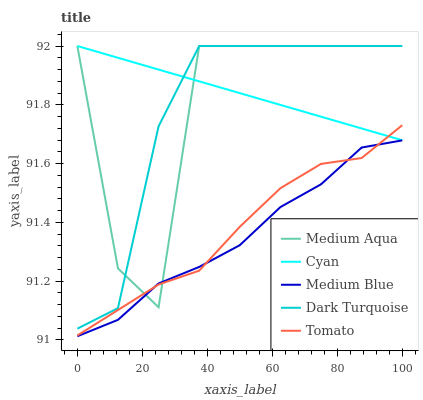Does Medium Blue have the minimum area under the curve?
Answer yes or no. Yes. Does Cyan have the maximum area under the curve?
Answer yes or no. Yes. Does Medium Aqua have the minimum area under the curve?
Answer yes or no. No. Does Medium Aqua have the maximum area under the curve?
Answer yes or no. No. Is Cyan the smoothest?
Answer yes or no. Yes. Is Medium Aqua the roughest?
Answer yes or no. Yes. Is Medium Aqua the smoothest?
Answer yes or no. No. Is Cyan the roughest?
Answer yes or no. No. Does Medium Blue have the lowest value?
Answer yes or no. Yes. Does Medium Aqua have the lowest value?
Answer yes or no. No. Does Dark Turquoise have the highest value?
Answer yes or no. Yes. Does Medium Blue have the highest value?
Answer yes or no. No. Is Medium Blue less than Cyan?
Answer yes or no. Yes. Is Dark Turquoise greater than Medium Blue?
Answer yes or no. Yes. Does Medium Blue intersect Medium Aqua?
Answer yes or no. Yes. Is Medium Blue less than Medium Aqua?
Answer yes or no. No. Is Medium Blue greater than Medium Aqua?
Answer yes or no. No. Does Medium Blue intersect Cyan?
Answer yes or no. No. 